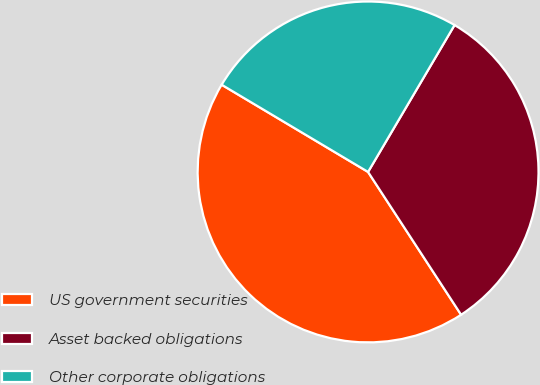<chart> <loc_0><loc_0><loc_500><loc_500><pie_chart><fcel>US government securities<fcel>Asset backed obligations<fcel>Other corporate obligations<nl><fcel>42.74%<fcel>32.34%<fcel>24.92%<nl></chart> 